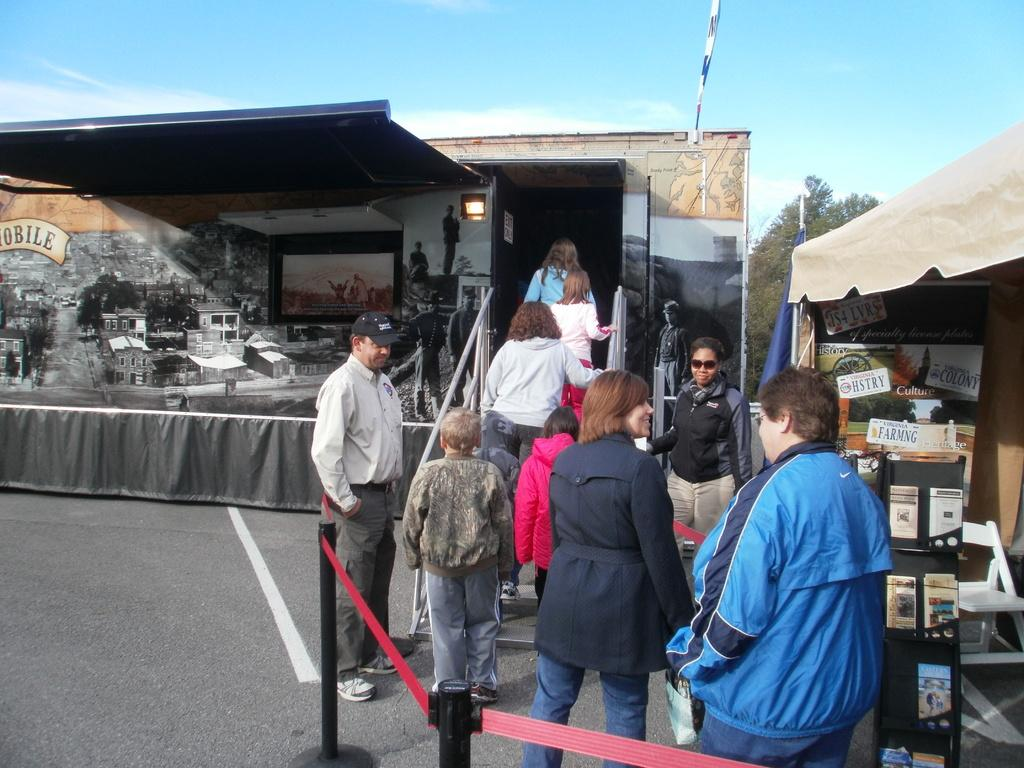<image>
Describe the image concisely. People are lined up to enter a trailer, passing a tent with information about Virginia history as they wait. 